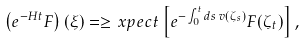Convert formula to latex. <formula><loc_0><loc_0><loc_500><loc_500>\left ( e ^ { - H t } F \right ) ( \xi ) = \geq x p e c t \left [ e ^ { - \int _ { 0 } ^ { t } d s \, v ( \zeta _ { s } ) } F ( \zeta _ { t } ) \right ] ,</formula> 